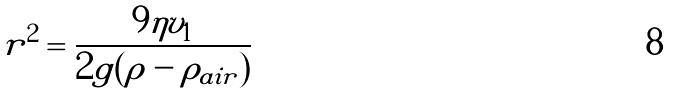Convert formula to latex. <formula><loc_0><loc_0><loc_500><loc_500>r ^ { 2 } = \frac { 9 \eta v _ { 1 } } { 2 g ( \rho - \rho _ { a i r } ) }</formula> 